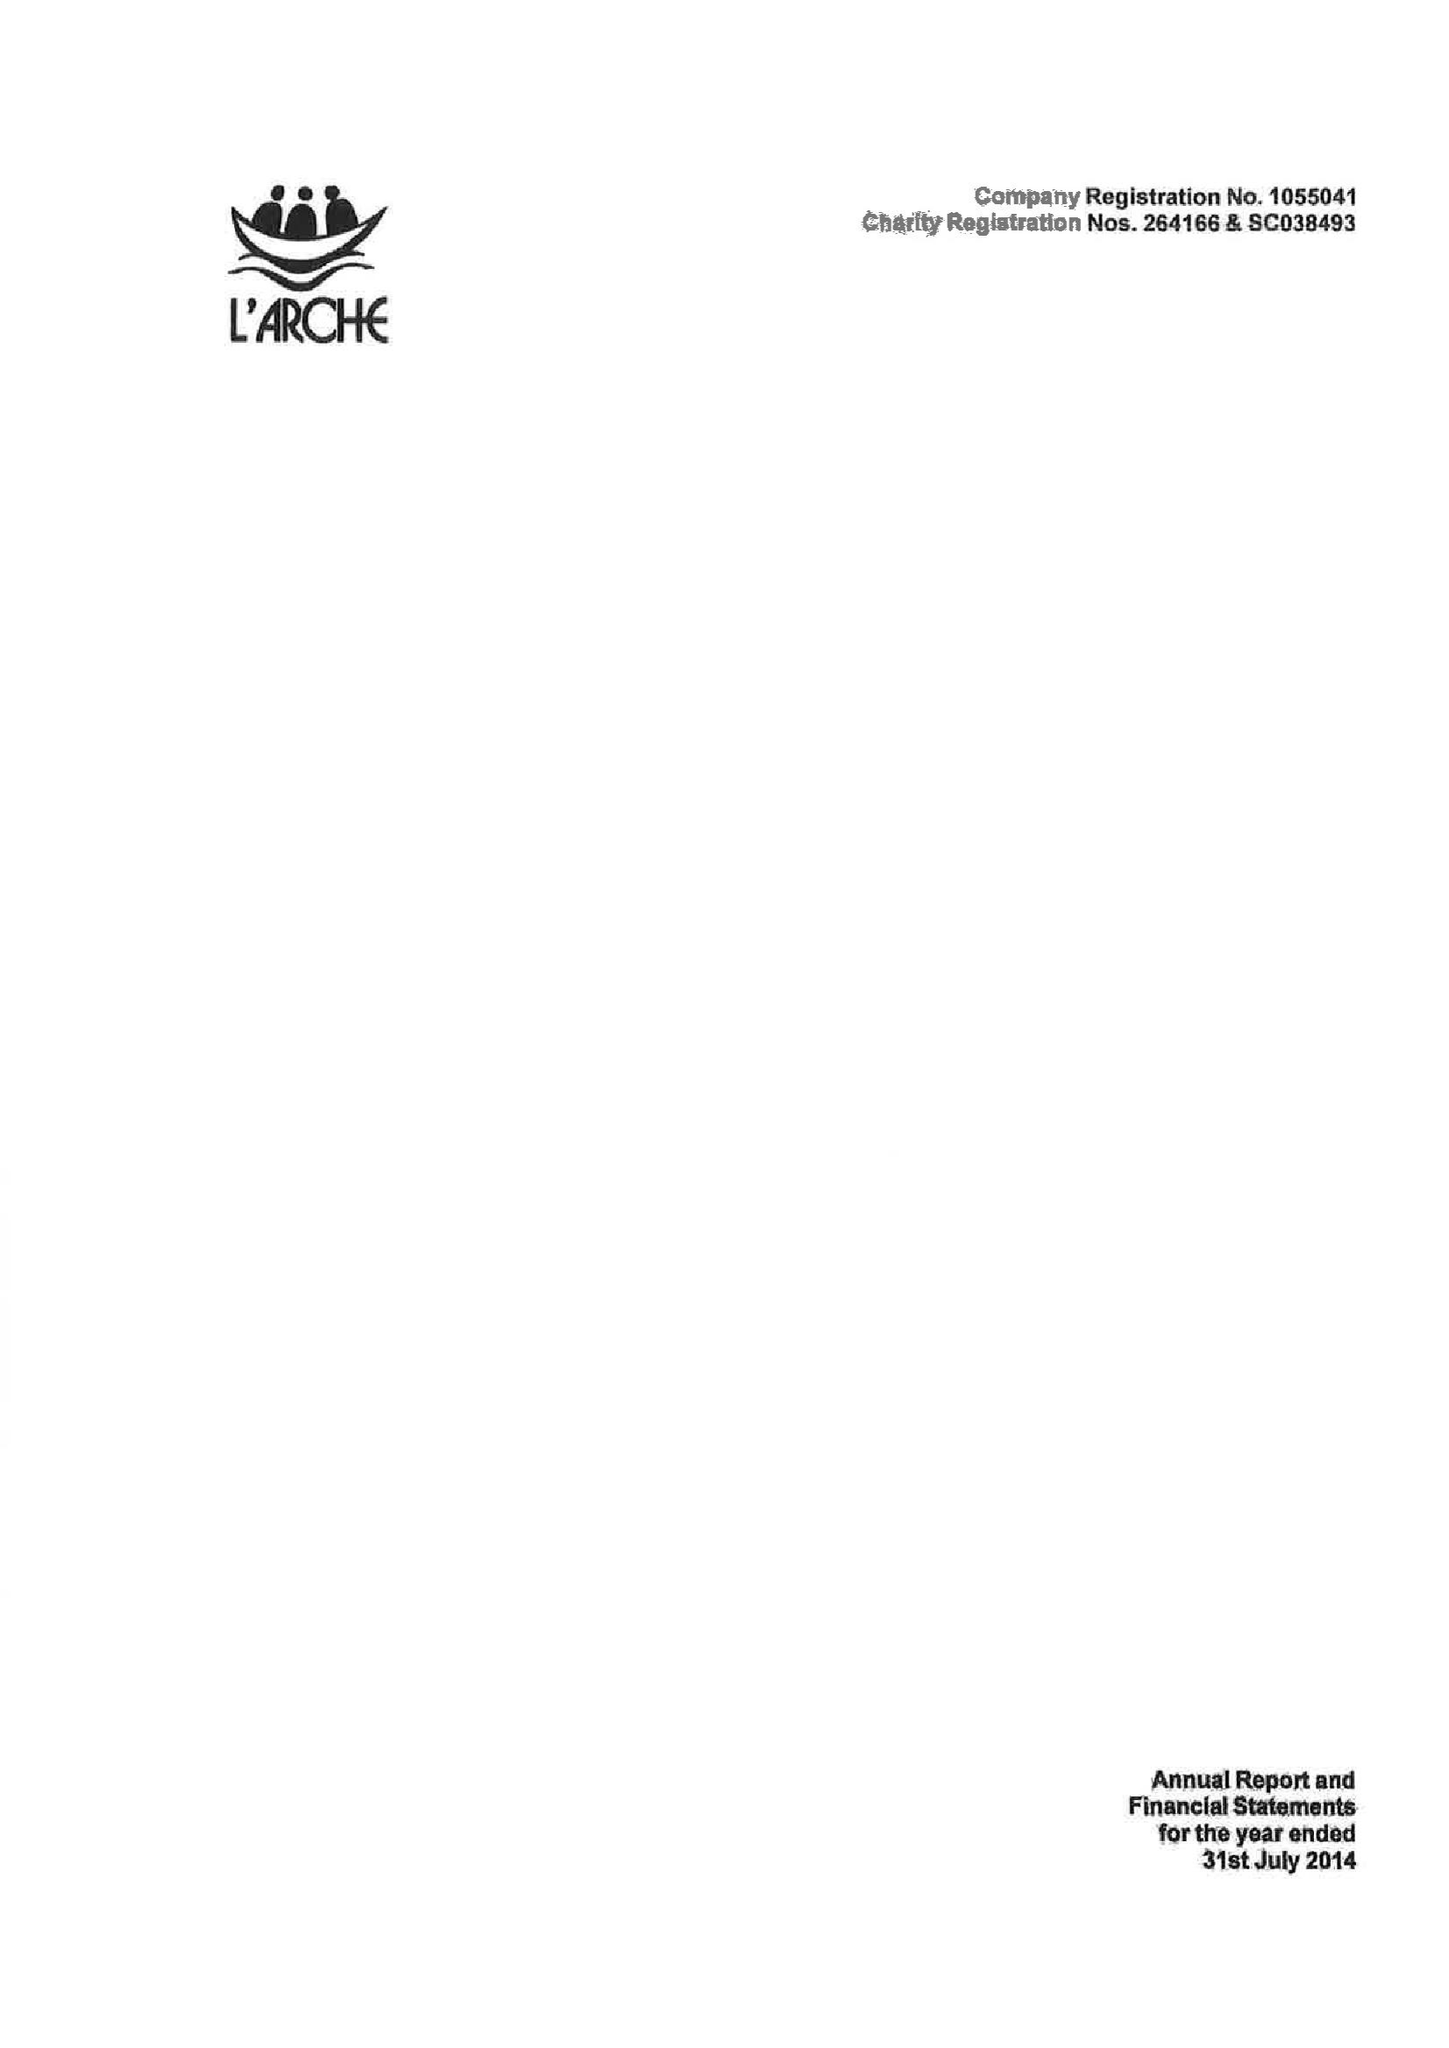What is the value for the charity_name?
Answer the question using a single word or phrase. L'arche 